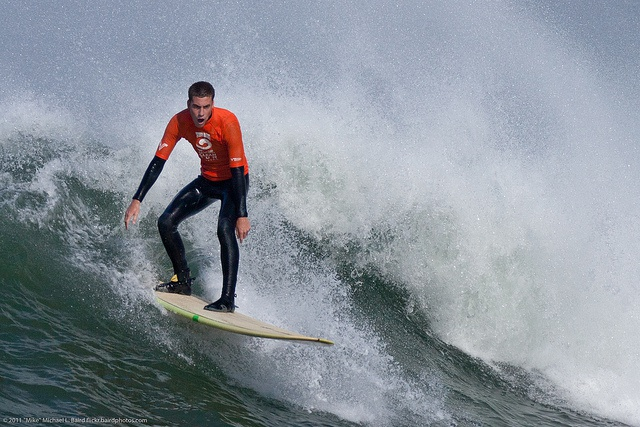Describe the objects in this image and their specific colors. I can see people in darkgray, black, maroon, gray, and brown tones and surfboard in darkgray, tan, olive, and gray tones in this image. 